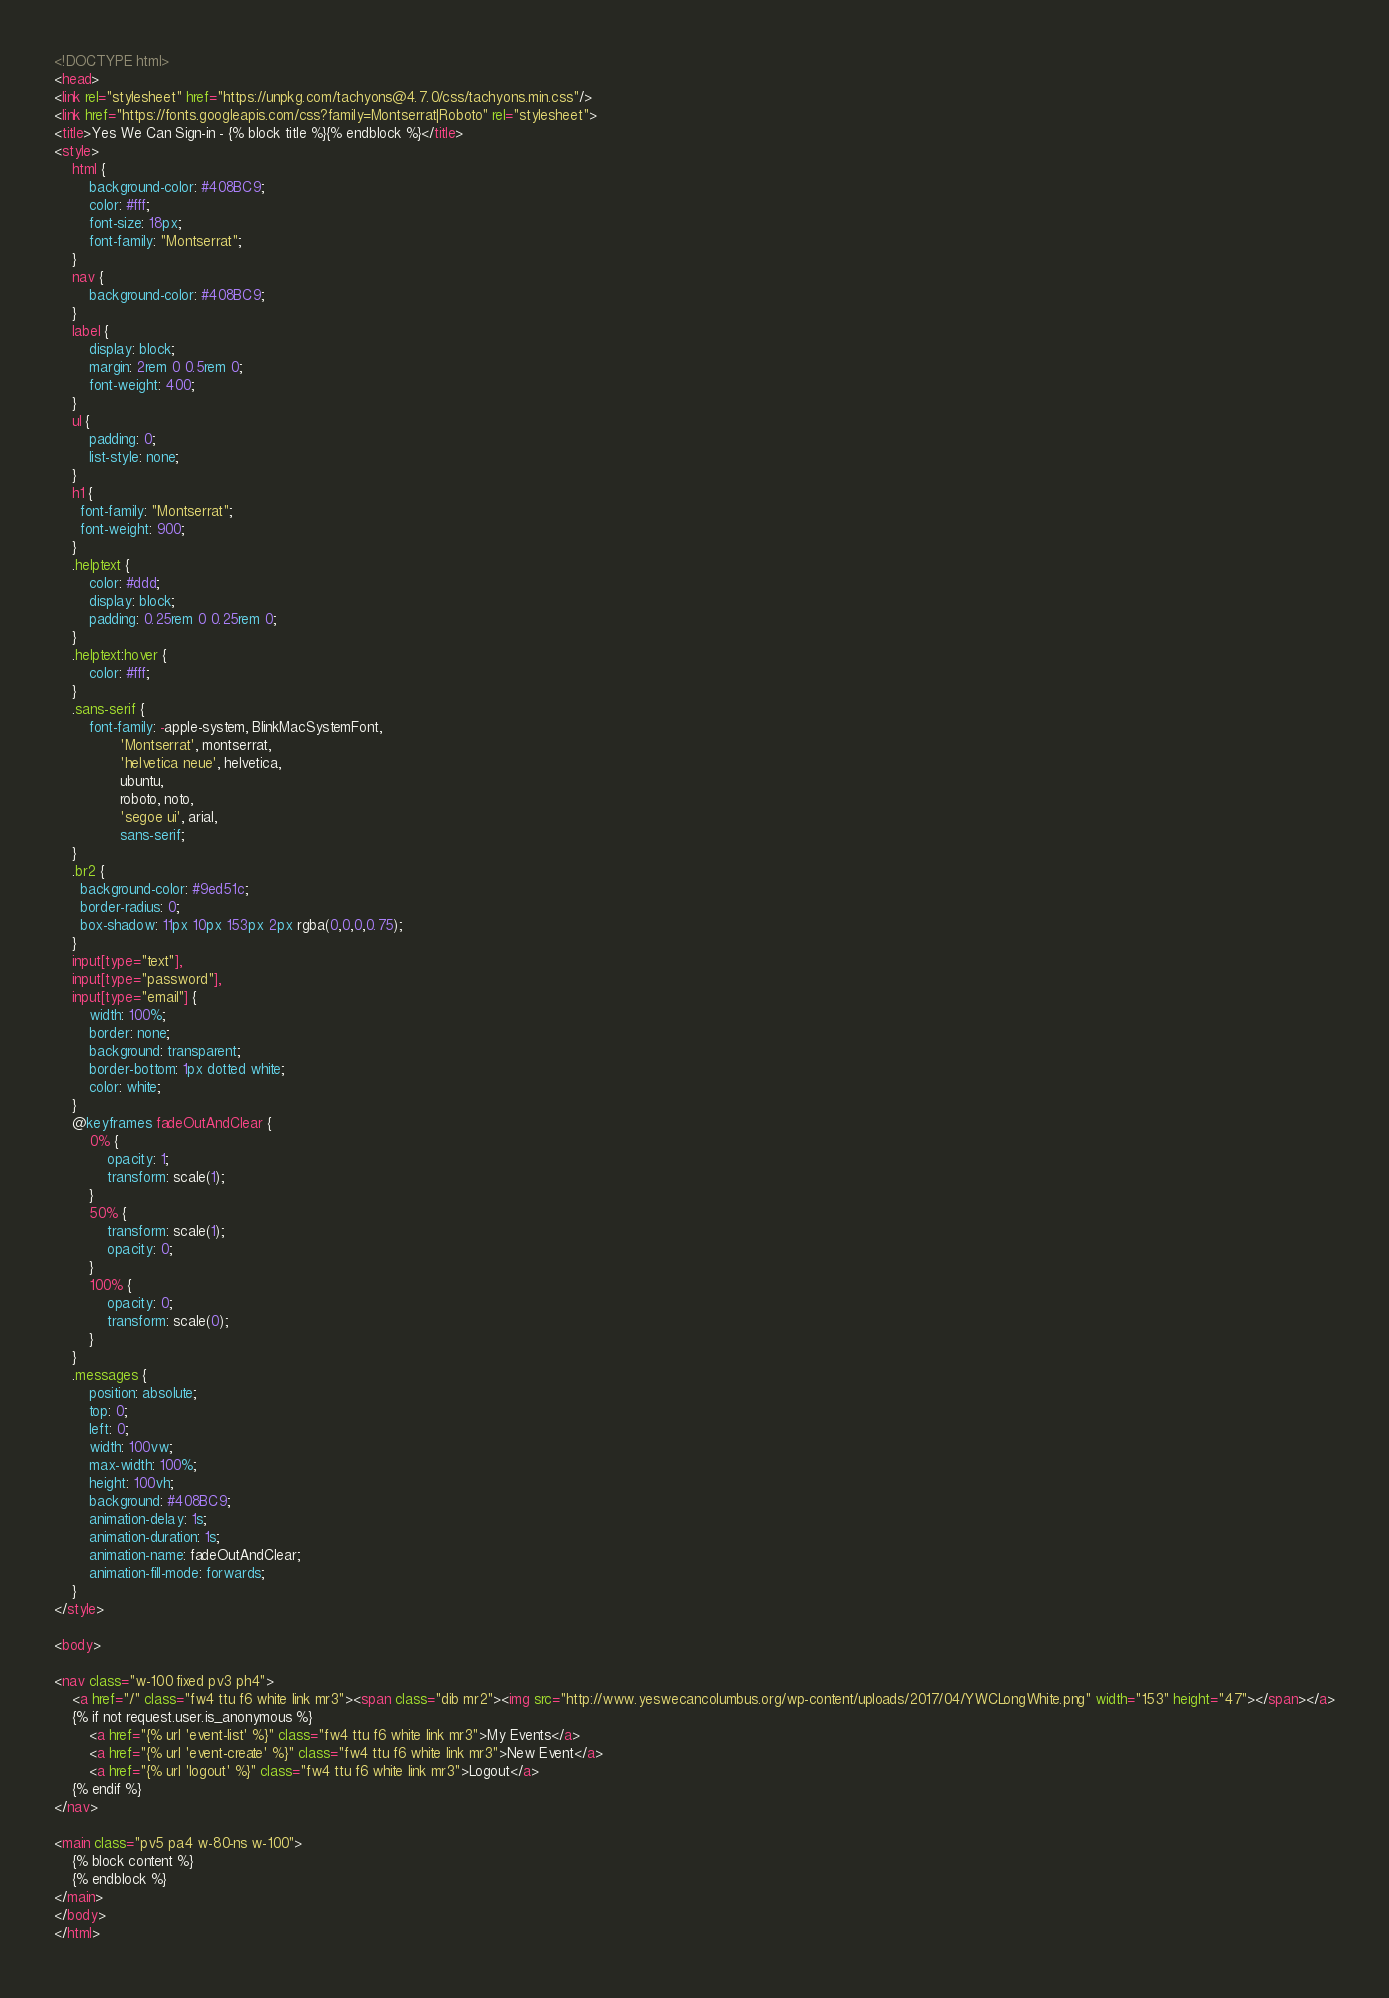Convert code to text. <code><loc_0><loc_0><loc_500><loc_500><_HTML_><!DOCTYPE html>
<head>
<link rel="stylesheet" href="https://unpkg.com/tachyons@4.7.0/css/tachyons.min.css"/>
<link href="https://fonts.googleapis.com/css?family=Montserrat|Roboto" rel="stylesheet">
<title>Yes We Can Sign-in - {% block title %}{% endblock %}</title>
<style>
    html {
        background-color: #408BC9;
        color: #fff;
        font-size: 18px;
        font-family: "Montserrat";
    }
    nav {
        background-color: #408BC9;
    }
    label {
        display: block;
        margin: 2rem 0 0.5rem 0;
        font-weight: 400;
    }
    ul {
        padding: 0;
        list-style: none;
    }
    h1 {
      font-family: "Montserrat";
      font-weight: 900;
    }
    .helptext {
        color: #ddd;
        display: block;
        padding: 0.25rem 0 0.25rem 0;
    }
    .helptext:hover {
        color: #fff;
    }
    .sans-serif {
        font-family: -apple-system, BlinkMacSystemFont,
               'Montserrat', montserrat,
               'helvetica neue', helvetica,
               ubuntu,
               roboto, noto,
               'segoe ui', arial,
               sans-serif;
    }
    .br2 {
      background-color: #9ed51c;
      border-radius: 0;
      box-shadow: 11px 10px 153px 2px rgba(0,0,0,0.75);
    }
    input[type="text"],
    input[type="password"],
    input[type="email"] {
        width: 100%;
        border: none;
        background: transparent;
        border-bottom: 1px dotted white;
        color: white;
    }
    @keyframes fadeOutAndClear {
        0% {
            opacity: 1;
            transform: scale(1);
        }
        50% {
            transform: scale(1);
            opacity: 0;
        }
        100% {
            opacity: 0;
            transform: scale(0);
        }
    }
    .messages {
        position: absolute;
        top: 0;
        left: 0;
        width: 100vw;
        max-width: 100%;
        height: 100vh;
        background: #408BC9;
        animation-delay: 1s;
        animation-duration: 1s;
        animation-name: fadeOutAndClear;
        animation-fill-mode: forwards;
    }
</style>

<body>

<nav class="w-100 fixed pv3 ph4">
    <a href="/" class="fw4 ttu f6 white link mr3"><span class="dib mr2"><img src="http://www.yeswecancolumbus.org/wp-content/uploads/2017/04/YWCLongWhite.png" width="153" height="47"></span></a>
    {% if not request.user.is_anonymous %}
        <a href="{% url 'event-list' %}" class="fw4 ttu f6 white link mr3">My Events</a>
        <a href="{% url 'event-create' %}" class="fw4 ttu f6 white link mr3">New Event</a>
        <a href="{% url 'logout' %}" class="fw4 ttu f6 white link mr3">Logout</a>
    {% endif %}
</nav>

<main class="pv5 pa4 w-80-ns w-100">
    {% block content %}
    {% endblock %}
</main>
</body>
</html>
</code> 